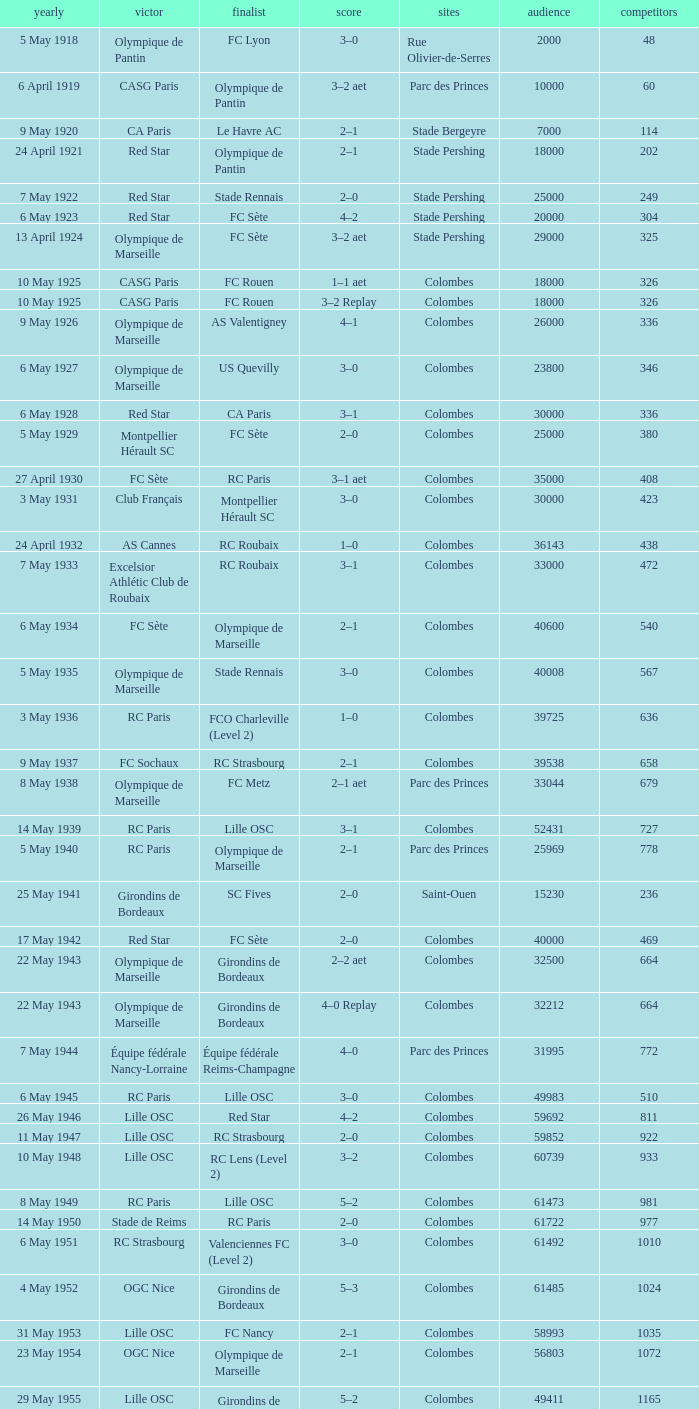What is the fewest recorded entrants against paris saint-germain? 6394.0. 